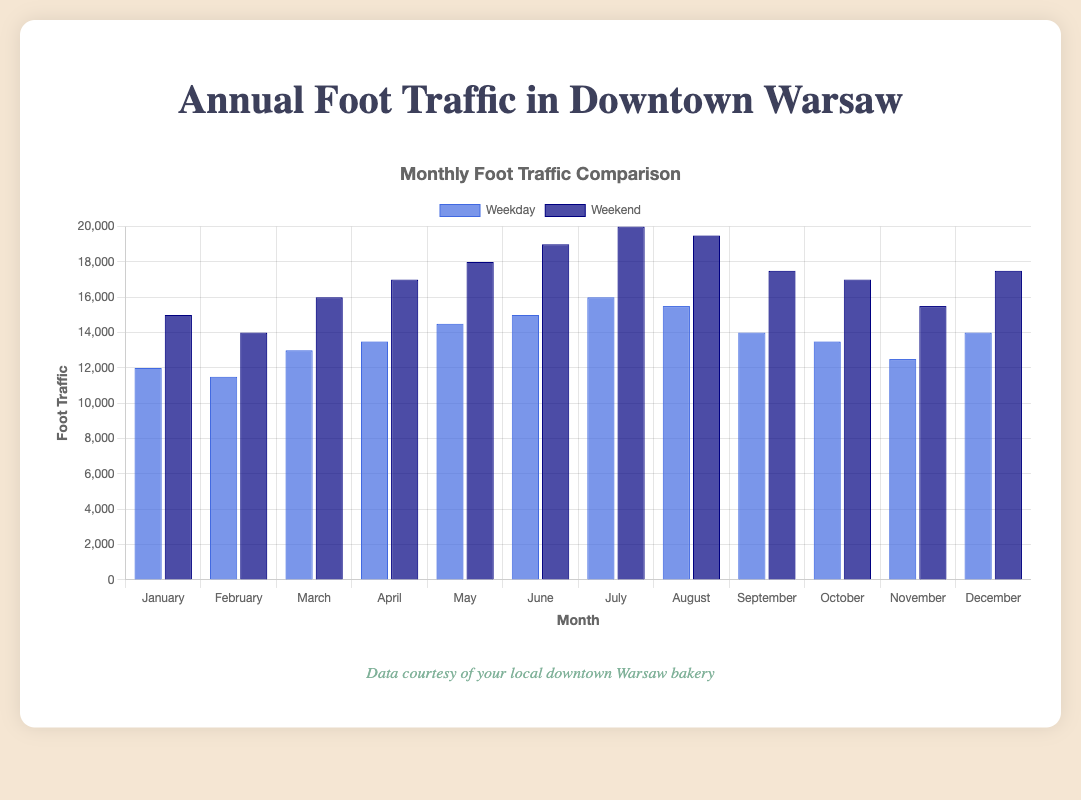What's the month with the highest foot traffic on weekends? The month with the highest foot traffic on weekends is July with 20,000 visitors. This is observed by comparing the height of the dark blue bars for each month.
Answer: July Which month shows a higher total foot traffic, March or April? To determine this, sum the foot traffic for weekdays and weekends for each month. March: 13,000 (Weekday) + 16,000 (Weekend) = 29,000; April: 13,500 (Weekday) + 17,000 (Weekend) = 30,500. So, April has a higher total foot traffic.
Answer: April What is the difference between weekday and weekend foot traffic in June? The June weekday foot traffic is 15,000, and weekend foot traffic is 19,000. The difference can be calculated as 19,000 - 15,000 = 4,000.
Answer: 4,000 How much more foot traffic is there on weekends compared to weekdays in December? December foot traffic for weekdays is 14,000 and for weekends is 17,500. The difference is 17,500 - 14,000 = 3,500 more on weekends.
Answer: 3,500 Is the foot traffic in May on weekends higher than foot traffic in February on weekends? Compare the heights of the dark blue bars for May and February. May has 18,000 and February has 14,000, so May is higher.
Answer: Yes What color represents weekday foot traffic in the bar chart? The color that represents weekday foot traffic is blue, as indicated by the legend in the chart.
Answer: Blue Which month shows the lowest foot traffic on weekdays? The month with the lowest foot traffic on weekdays is February with 11,500 visitors. This can be concluded by comparing the height of the blue bars for each month.
Answer: February Calculate the average weekend foot traffic for the entire year. Sum the weekend foot traffic for all months (15,000 + 14,000 + 16,000 + 17,000 + 18,000 + 19,000 + 20,000 + 19,500 + 17,500 + 17,000 + 15,500 + 17,500 = 206,000). Then divide by the number of months (206,000 / 12). The average weekend foot traffic is 17,166.67.
Answer: 17,166.67 